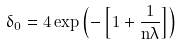Convert formula to latex. <formula><loc_0><loc_0><loc_500><loc_500>\delta _ { 0 } = 4 \exp \left ( - \left [ 1 + \frac { 1 } { n \lambda } \right ] \right )</formula> 